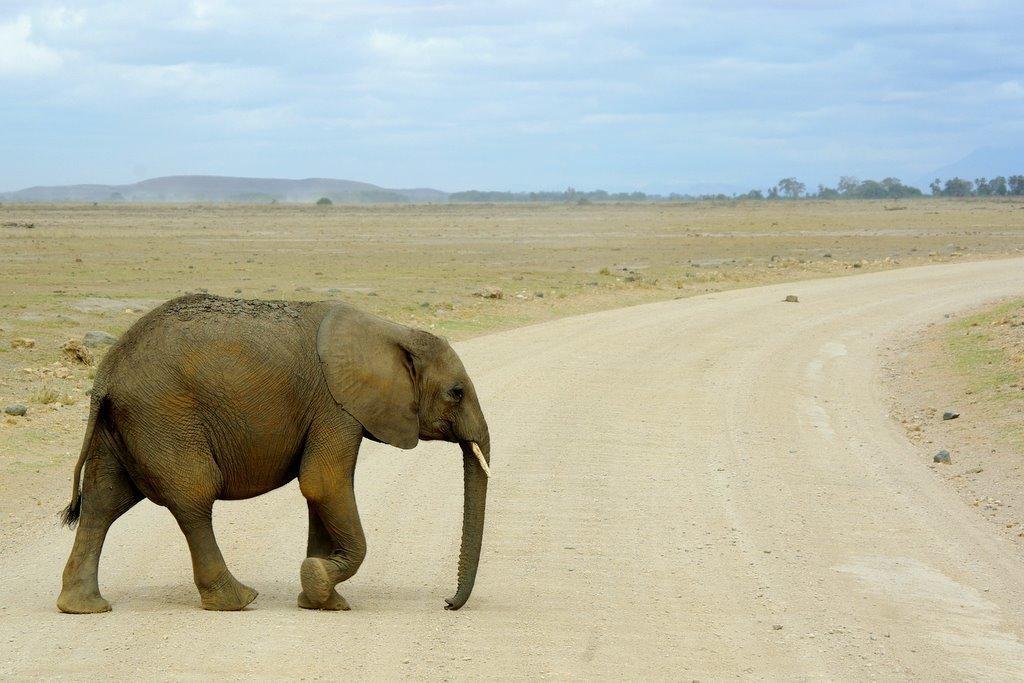Can you describe this image briefly? In this image there is an elephant walking on the road surface, in the background of the image there are mountains and trees. 